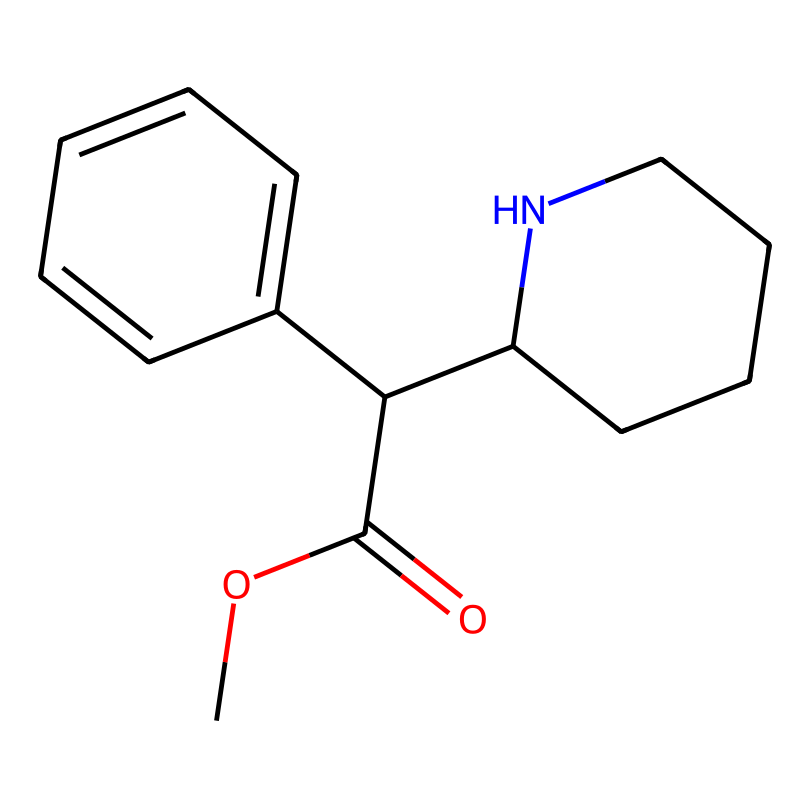How many carbon atoms are in the structure? The structure contains four distinct carbon atoms in the main chain and three additional carbon atoms in the two aromatic rings, totaling seven carbon atoms.
Answer: seven What type of functional group is present in methylphenidate? The structure shows a carbonyl group (C=O) associated with a carboxylic acid derivative, indicating that the functional group is an ester, highlighted by the ester linkage in the molecule.
Answer: ester How many nitrogen atoms are present in the chemical? Upon analyzing the structure, there is only one nitrogen atom which can be clearly identified as part of the piperidine ring within the chemical's structure.
Answer: one Which part of this structure is likely responsible for the central nervous system effects? The piperidine ring structure, due to its ability to interact with neurotransmitter systems, is likely responsible for the drug's central nervous system stimulant effects, reflecting its influence on ADHD treatment.
Answer: piperidine ring What is the molecular formula of methylphenidate? By counting the atoms from the SMILES representation, we can derive the molecular formula as C14H19NO2, indicating the combined number of carbon, hydrogen, nitrogen, and oxygen atoms in the structure.
Answer: C14H19NO2 